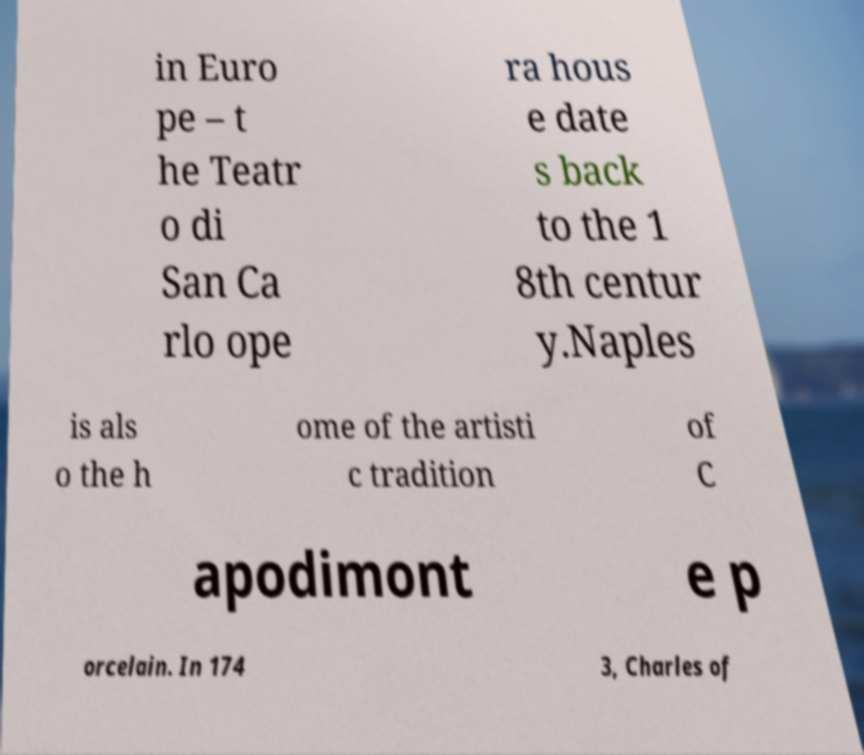Please identify and transcribe the text found in this image. in Euro pe – t he Teatr o di San Ca rlo ope ra hous e date s back to the 1 8th centur y.Naples is als o the h ome of the artisti c tradition of C apodimont e p orcelain. In 174 3, Charles of 